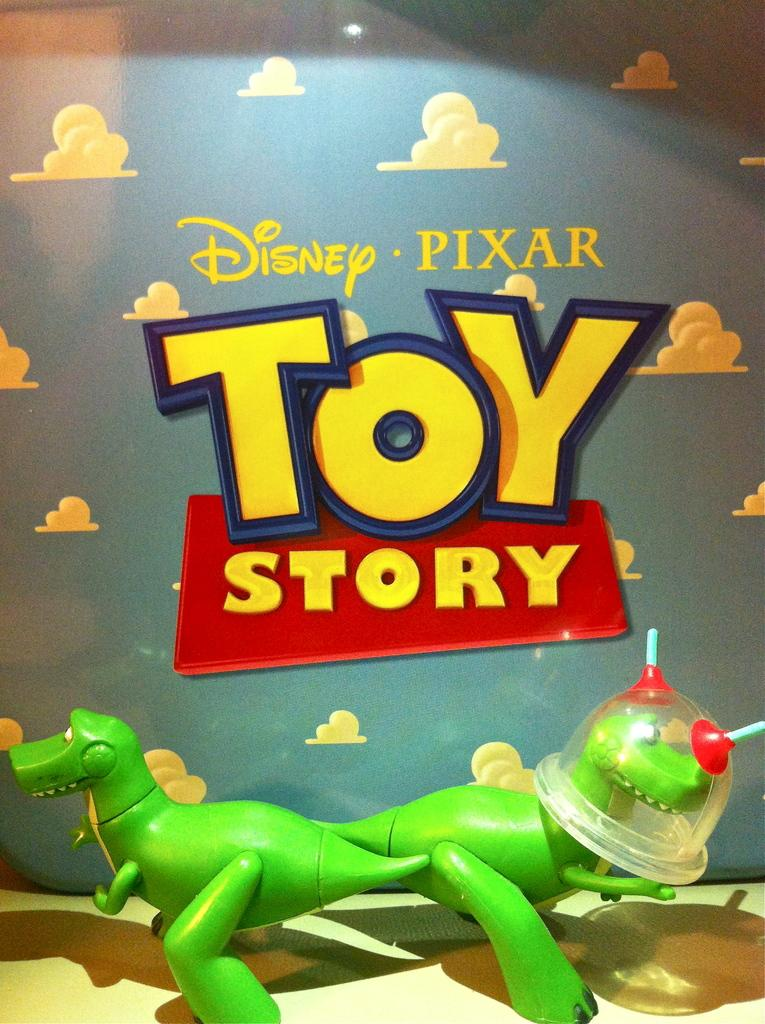What objects can be seen in the image? There are toys in the image. What can be seen in the background of the image? There is a hoarding in the background of the image. What type of clouds can be seen in the image? There are no clouds visible in the image; it only features toys and a hoarding. Can you provide a receipt for the toys in the image? There is no receipt present in the image, as it is a still photograph and not a transaction. 